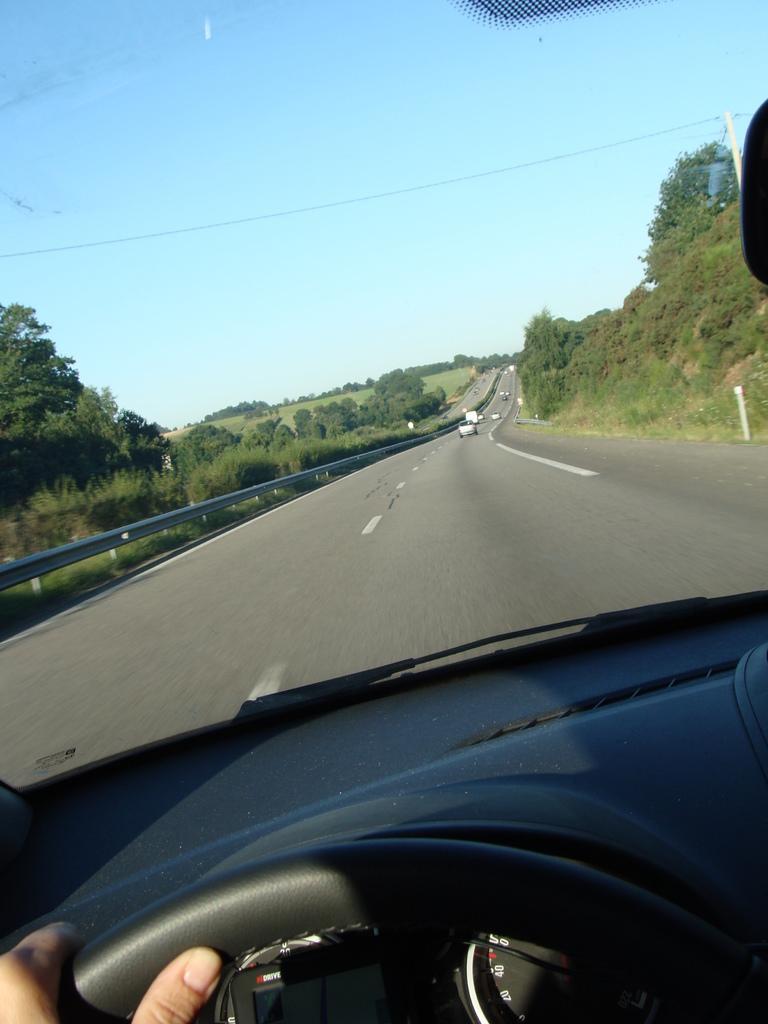Please provide a concise description of this image. This is inside view of a car where we can see a person hand on the steering,through the front glass door of the car we can see vehicles on the road,fence,pole,trees,grass and sky. 